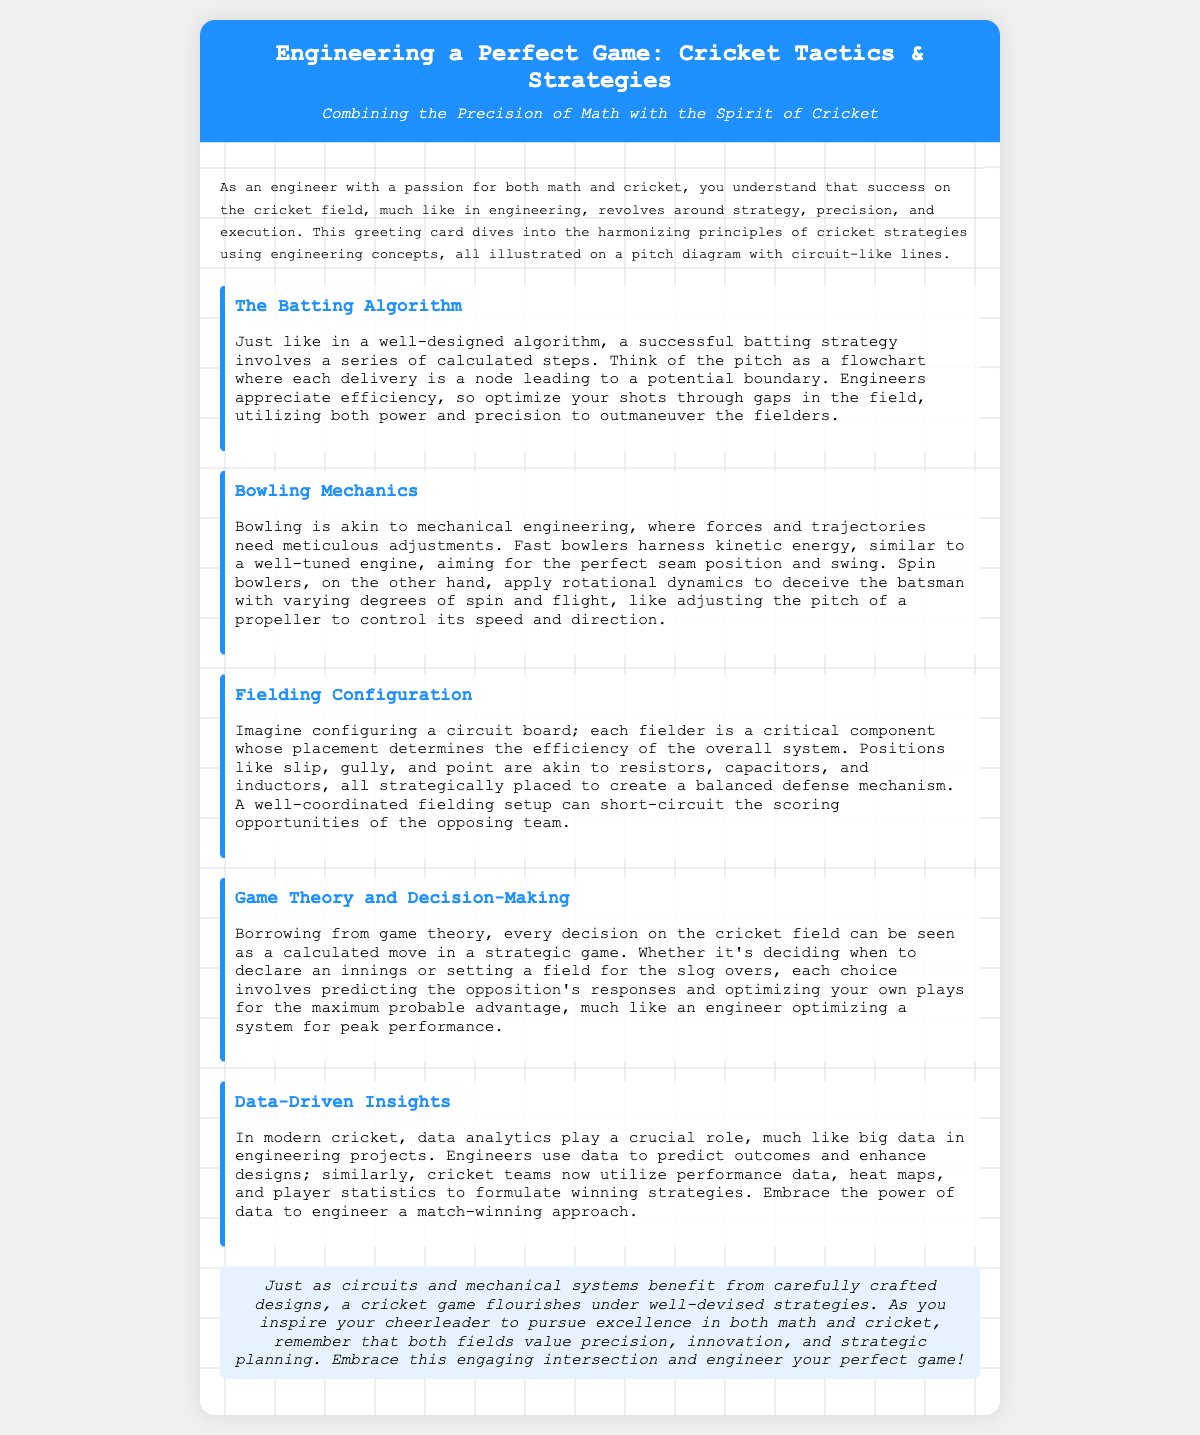what is the title of the card? The title of the card is mentioned prominently at the top, indicating the main focus of the content.
Answer: Engineering a Perfect Game: Cricket Tactics & Strategies what concept is compared to bowling? Bowling is compared to a mechanical engineering principle, highlighting the adjustments needed for execution.
Answer: Mechanical engineering which strategy is compared to an algorithm? The batting strategy is likened to a well-designed algorithm in the content.
Answer: Batting strategy what aspect of cricket does data analytics relate to? Data analytics is related to modern cricket strategy, emphasizing its importance in formulating winning plays.
Answer: Strategy what role do fielders play in the cricket game? Fielders are considered critical components, similar to elements in a circuit, determining defensive efficiency.
Answer: Critical components which principle is emphasized in decision-making on the field? The principle of game theory is highlighted to illustrate the decision-making process in cricket.
Answer: Game theory who inspires the cheerleader according to the content? The card implies that the engineer is the one inspiring the cheerleader in their pursuits.
Answer: Engineer what two fields are combined in the theme of the card? The card combines the fields of cricket and engineering, showcasing their intersection.
Answer: Cricket and engineering 